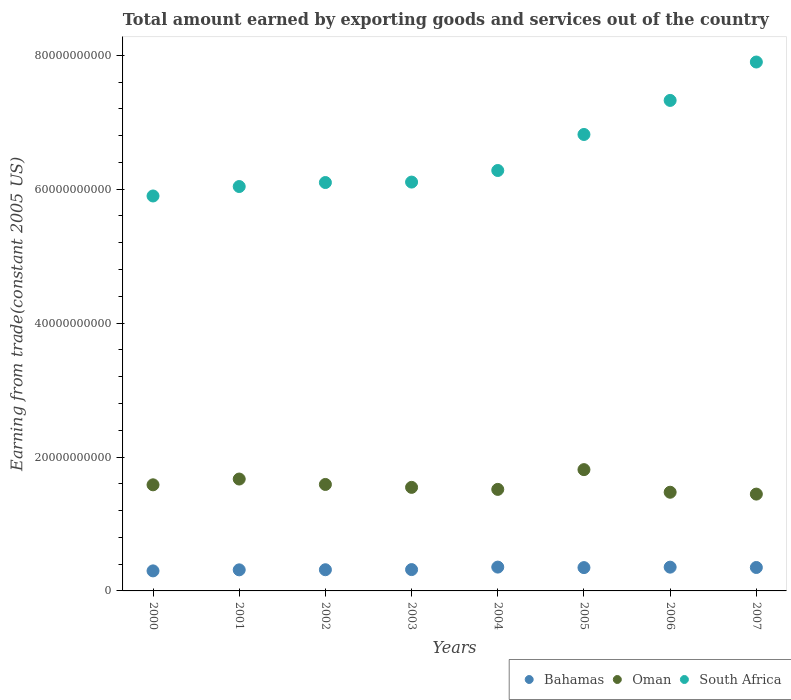How many different coloured dotlines are there?
Keep it short and to the point. 3. Is the number of dotlines equal to the number of legend labels?
Give a very brief answer. Yes. What is the total amount earned by exporting goods and services in Bahamas in 2007?
Your answer should be compact. 3.50e+09. Across all years, what is the maximum total amount earned by exporting goods and services in Oman?
Make the answer very short. 1.81e+1. Across all years, what is the minimum total amount earned by exporting goods and services in South Africa?
Offer a very short reply. 5.90e+1. In which year was the total amount earned by exporting goods and services in South Africa maximum?
Your answer should be very brief. 2007. What is the total total amount earned by exporting goods and services in Oman in the graph?
Give a very brief answer. 1.26e+11. What is the difference between the total amount earned by exporting goods and services in Bahamas in 2001 and that in 2004?
Provide a succinct answer. -4.10e+08. What is the difference between the total amount earned by exporting goods and services in South Africa in 2002 and the total amount earned by exporting goods and services in Bahamas in 2007?
Ensure brevity in your answer.  5.75e+1. What is the average total amount earned by exporting goods and services in Bahamas per year?
Make the answer very short. 3.32e+09. In the year 2002, what is the difference between the total amount earned by exporting goods and services in Bahamas and total amount earned by exporting goods and services in South Africa?
Make the answer very short. -5.78e+1. What is the ratio of the total amount earned by exporting goods and services in South Africa in 2003 to that in 2004?
Provide a short and direct response. 0.97. What is the difference between the highest and the second highest total amount earned by exporting goods and services in South Africa?
Offer a terse response. 5.73e+09. What is the difference between the highest and the lowest total amount earned by exporting goods and services in Bahamas?
Keep it short and to the point. 5.66e+08. In how many years, is the total amount earned by exporting goods and services in South Africa greater than the average total amount earned by exporting goods and services in South Africa taken over all years?
Provide a short and direct response. 3. Is the sum of the total amount earned by exporting goods and services in South Africa in 2001 and 2005 greater than the maximum total amount earned by exporting goods and services in Bahamas across all years?
Ensure brevity in your answer.  Yes. How many dotlines are there?
Your response must be concise. 3. Are the values on the major ticks of Y-axis written in scientific E-notation?
Ensure brevity in your answer.  No. Where does the legend appear in the graph?
Offer a terse response. Bottom right. How many legend labels are there?
Make the answer very short. 3. What is the title of the graph?
Your response must be concise. Total amount earned by exporting goods and services out of the country. What is the label or title of the Y-axis?
Ensure brevity in your answer.  Earning from trade(constant 2005 US). What is the Earning from trade(constant 2005 US) in Bahamas in 2000?
Provide a short and direct response. 2.99e+09. What is the Earning from trade(constant 2005 US) in Oman in 2000?
Offer a very short reply. 1.58e+1. What is the Earning from trade(constant 2005 US) in South Africa in 2000?
Make the answer very short. 5.90e+1. What is the Earning from trade(constant 2005 US) of Bahamas in 2001?
Provide a succinct answer. 3.15e+09. What is the Earning from trade(constant 2005 US) in Oman in 2001?
Ensure brevity in your answer.  1.67e+1. What is the Earning from trade(constant 2005 US) of South Africa in 2001?
Offer a very short reply. 6.04e+1. What is the Earning from trade(constant 2005 US) of Bahamas in 2002?
Provide a succinct answer. 3.16e+09. What is the Earning from trade(constant 2005 US) of Oman in 2002?
Your answer should be compact. 1.59e+1. What is the Earning from trade(constant 2005 US) in South Africa in 2002?
Provide a short and direct response. 6.10e+1. What is the Earning from trade(constant 2005 US) of Bahamas in 2003?
Your answer should be compact. 3.19e+09. What is the Earning from trade(constant 2005 US) of Oman in 2003?
Provide a short and direct response. 1.55e+1. What is the Earning from trade(constant 2005 US) of South Africa in 2003?
Your answer should be compact. 6.11e+1. What is the Earning from trade(constant 2005 US) in Bahamas in 2004?
Make the answer very short. 3.56e+09. What is the Earning from trade(constant 2005 US) of Oman in 2004?
Keep it short and to the point. 1.52e+1. What is the Earning from trade(constant 2005 US) in South Africa in 2004?
Make the answer very short. 6.28e+1. What is the Earning from trade(constant 2005 US) in Bahamas in 2005?
Provide a succinct answer. 3.48e+09. What is the Earning from trade(constant 2005 US) in Oman in 2005?
Make the answer very short. 1.81e+1. What is the Earning from trade(constant 2005 US) in South Africa in 2005?
Your response must be concise. 6.82e+1. What is the Earning from trade(constant 2005 US) of Bahamas in 2006?
Offer a terse response. 3.55e+09. What is the Earning from trade(constant 2005 US) in Oman in 2006?
Offer a terse response. 1.47e+1. What is the Earning from trade(constant 2005 US) of South Africa in 2006?
Your response must be concise. 7.33e+1. What is the Earning from trade(constant 2005 US) of Bahamas in 2007?
Ensure brevity in your answer.  3.50e+09. What is the Earning from trade(constant 2005 US) in Oman in 2007?
Provide a succinct answer. 1.45e+1. What is the Earning from trade(constant 2005 US) in South Africa in 2007?
Your answer should be compact. 7.90e+1. Across all years, what is the maximum Earning from trade(constant 2005 US) of Bahamas?
Your answer should be very brief. 3.56e+09. Across all years, what is the maximum Earning from trade(constant 2005 US) in Oman?
Your response must be concise. 1.81e+1. Across all years, what is the maximum Earning from trade(constant 2005 US) in South Africa?
Your answer should be compact. 7.90e+1. Across all years, what is the minimum Earning from trade(constant 2005 US) of Bahamas?
Ensure brevity in your answer.  2.99e+09. Across all years, what is the minimum Earning from trade(constant 2005 US) of Oman?
Your response must be concise. 1.45e+1. Across all years, what is the minimum Earning from trade(constant 2005 US) in South Africa?
Offer a very short reply. 5.90e+1. What is the total Earning from trade(constant 2005 US) of Bahamas in the graph?
Your answer should be compact. 2.66e+1. What is the total Earning from trade(constant 2005 US) in Oman in the graph?
Give a very brief answer. 1.26e+11. What is the total Earning from trade(constant 2005 US) in South Africa in the graph?
Offer a very short reply. 5.25e+11. What is the difference between the Earning from trade(constant 2005 US) of Bahamas in 2000 and that in 2001?
Give a very brief answer. -1.55e+08. What is the difference between the Earning from trade(constant 2005 US) of Oman in 2000 and that in 2001?
Provide a succinct answer. -8.64e+08. What is the difference between the Earning from trade(constant 2005 US) in South Africa in 2000 and that in 2001?
Your answer should be very brief. -1.41e+09. What is the difference between the Earning from trade(constant 2005 US) in Bahamas in 2000 and that in 2002?
Keep it short and to the point. -1.72e+08. What is the difference between the Earning from trade(constant 2005 US) of Oman in 2000 and that in 2002?
Keep it short and to the point. -5.48e+07. What is the difference between the Earning from trade(constant 2005 US) of South Africa in 2000 and that in 2002?
Provide a short and direct response. -2.01e+09. What is the difference between the Earning from trade(constant 2005 US) of Bahamas in 2000 and that in 2003?
Your response must be concise. -1.93e+08. What is the difference between the Earning from trade(constant 2005 US) in Oman in 2000 and that in 2003?
Your answer should be very brief. 3.80e+08. What is the difference between the Earning from trade(constant 2005 US) of South Africa in 2000 and that in 2003?
Offer a terse response. -2.08e+09. What is the difference between the Earning from trade(constant 2005 US) in Bahamas in 2000 and that in 2004?
Offer a very short reply. -5.66e+08. What is the difference between the Earning from trade(constant 2005 US) of Oman in 2000 and that in 2004?
Offer a very short reply. 6.82e+08. What is the difference between the Earning from trade(constant 2005 US) of South Africa in 2000 and that in 2004?
Offer a very short reply. -3.81e+09. What is the difference between the Earning from trade(constant 2005 US) of Bahamas in 2000 and that in 2005?
Provide a short and direct response. -4.90e+08. What is the difference between the Earning from trade(constant 2005 US) of Oman in 2000 and that in 2005?
Provide a short and direct response. -2.27e+09. What is the difference between the Earning from trade(constant 2005 US) in South Africa in 2000 and that in 2005?
Your response must be concise. -9.19e+09. What is the difference between the Earning from trade(constant 2005 US) in Bahamas in 2000 and that in 2006?
Your answer should be compact. -5.57e+08. What is the difference between the Earning from trade(constant 2005 US) in Oman in 2000 and that in 2006?
Your response must be concise. 1.11e+09. What is the difference between the Earning from trade(constant 2005 US) in South Africa in 2000 and that in 2006?
Keep it short and to the point. -1.43e+1. What is the difference between the Earning from trade(constant 2005 US) in Bahamas in 2000 and that in 2007?
Your answer should be very brief. -5.07e+08. What is the difference between the Earning from trade(constant 2005 US) of Oman in 2000 and that in 2007?
Provide a succinct answer. 1.39e+09. What is the difference between the Earning from trade(constant 2005 US) of South Africa in 2000 and that in 2007?
Give a very brief answer. -2.00e+1. What is the difference between the Earning from trade(constant 2005 US) in Bahamas in 2001 and that in 2002?
Ensure brevity in your answer.  -1.64e+07. What is the difference between the Earning from trade(constant 2005 US) of Oman in 2001 and that in 2002?
Ensure brevity in your answer.  8.09e+08. What is the difference between the Earning from trade(constant 2005 US) in South Africa in 2001 and that in 2002?
Your response must be concise. -5.97e+08. What is the difference between the Earning from trade(constant 2005 US) in Bahamas in 2001 and that in 2003?
Ensure brevity in your answer.  -3.78e+07. What is the difference between the Earning from trade(constant 2005 US) in Oman in 2001 and that in 2003?
Your response must be concise. 1.24e+09. What is the difference between the Earning from trade(constant 2005 US) in South Africa in 2001 and that in 2003?
Make the answer very short. -6.64e+08. What is the difference between the Earning from trade(constant 2005 US) in Bahamas in 2001 and that in 2004?
Your response must be concise. -4.10e+08. What is the difference between the Earning from trade(constant 2005 US) in Oman in 2001 and that in 2004?
Your response must be concise. 1.55e+09. What is the difference between the Earning from trade(constant 2005 US) of South Africa in 2001 and that in 2004?
Make the answer very short. -2.39e+09. What is the difference between the Earning from trade(constant 2005 US) of Bahamas in 2001 and that in 2005?
Give a very brief answer. -3.34e+08. What is the difference between the Earning from trade(constant 2005 US) of Oman in 2001 and that in 2005?
Keep it short and to the point. -1.40e+09. What is the difference between the Earning from trade(constant 2005 US) in South Africa in 2001 and that in 2005?
Offer a terse response. -7.77e+09. What is the difference between the Earning from trade(constant 2005 US) in Bahamas in 2001 and that in 2006?
Your response must be concise. -4.02e+08. What is the difference between the Earning from trade(constant 2005 US) of Oman in 2001 and that in 2006?
Give a very brief answer. 1.97e+09. What is the difference between the Earning from trade(constant 2005 US) in South Africa in 2001 and that in 2006?
Make the answer very short. -1.29e+1. What is the difference between the Earning from trade(constant 2005 US) in Bahamas in 2001 and that in 2007?
Ensure brevity in your answer.  -3.51e+08. What is the difference between the Earning from trade(constant 2005 US) of Oman in 2001 and that in 2007?
Offer a very short reply. 2.25e+09. What is the difference between the Earning from trade(constant 2005 US) of South Africa in 2001 and that in 2007?
Your response must be concise. -1.86e+1. What is the difference between the Earning from trade(constant 2005 US) of Bahamas in 2002 and that in 2003?
Your answer should be compact. -2.14e+07. What is the difference between the Earning from trade(constant 2005 US) in Oman in 2002 and that in 2003?
Ensure brevity in your answer.  4.35e+08. What is the difference between the Earning from trade(constant 2005 US) in South Africa in 2002 and that in 2003?
Offer a terse response. -6.67e+07. What is the difference between the Earning from trade(constant 2005 US) in Bahamas in 2002 and that in 2004?
Ensure brevity in your answer.  -3.94e+08. What is the difference between the Earning from trade(constant 2005 US) in Oman in 2002 and that in 2004?
Ensure brevity in your answer.  7.36e+08. What is the difference between the Earning from trade(constant 2005 US) in South Africa in 2002 and that in 2004?
Provide a succinct answer. -1.80e+09. What is the difference between the Earning from trade(constant 2005 US) of Bahamas in 2002 and that in 2005?
Provide a succinct answer. -3.18e+08. What is the difference between the Earning from trade(constant 2005 US) in Oman in 2002 and that in 2005?
Provide a short and direct response. -2.21e+09. What is the difference between the Earning from trade(constant 2005 US) of South Africa in 2002 and that in 2005?
Ensure brevity in your answer.  -7.18e+09. What is the difference between the Earning from trade(constant 2005 US) of Bahamas in 2002 and that in 2006?
Give a very brief answer. -3.86e+08. What is the difference between the Earning from trade(constant 2005 US) of Oman in 2002 and that in 2006?
Your answer should be compact. 1.16e+09. What is the difference between the Earning from trade(constant 2005 US) in South Africa in 2002 and that in 2006?
Your answer should be very brief. -1.23e+1. What is the difference between the Earning from trade(constant 2005 US) in Bahamas in 2002 and that in 2007?
Give a very brief answer. -3.35e+08. What is the difference between the Earning from trade(constant 2005 US) in Oman in 2002 and that in 2007?
Keep it short and to the point. 1.44e+09. What is the difference between the Earning from trade(constant 2005 US) in South Africa in 2002 and that in 2007?
Your answer should be compact. -1.80e+1. What is the difference between the Earning from trade(constant 2005 US) of Bahamas in 2003 and that in 2004?
Make the answer very short. -3.73e+08. What is the difference between the Earning from trade(constant 2005 US) in Oman in 2003 and that in 2004?
Your answer should be compact. 3.01e+08. What is the difference between the Earning from trade(constant 2005 US) in South Africa in 2003 and that in 2004?
Your answer should be very brief. -1.73e+09. What is the difference between the Earning from trade(constant 2005 US) of Bahamas in 2003 and that in 2005?
Ensure brevity in your answer.  -2.96e+08. What is the difference between the Earning from trade(constant 2005 US) in Oman in 2003 and that in 2005?
Make the answer very short. -2.65e+09. What is the difference between the Earning from trade(constant 2005 US) of South Africa in 2003 and that in 2005?
Keep it short and to the point. -7.11e+09. What is the difference between the Earning from trade(constant 2005 US) of Bahamas in 2003 and that in 2006?
Your response must be concise. -3.64e+08. What is the difference between the Earning from trade(constant 2005 US) of Oman in 2003 and that in 2006?
Give a very brief answer. 7.28e+08. What is the difference between the Earning from trade(constant 2005 US) in South Africa in 2003 and that in 2006?
Ensure brevity in your answer.  -1.22e+1. What is the difference between the Earning from trade(constant 2005 US) of Bahamas in 2003 and that in 2007?
Provide a short and direct response. -3.14e+08. What is the difference between the Earning from trade(constant 2005 US) of Oman in 2003 and that in 2007?
Give a very brief answer. 1.00e+09. What is the difference between the Earning from trade(constant 2005 US) in South Africa in 2003 and that in 2007?
Your response must be concise. -1.79e+1. What is the difference between the Earning from trade(constant 2005 US) in Bahamas in 2004 and that in 2005?
Your answer should be very brief. 7.62e+07. What is the difference between the Earning from trade(constant 2005 US) of Oman in 2004 and that in 2005?
Ensure brevity in your answer.  -2.95e+09. What is the difference between the Earning from trade(constant 2005 US) in South Africa in 2004 and that in 2005?
Your response must be concise. -5.38e+09. What is the difference between the Earning from trade(constant 2005 US) in Bahamas in 2004 and that in 2006?
Make the answer very short. 8.46e+06. What is the difference between the Earning from trade(constant 2005 US) of Oman in 2004 and that in 2006?
Provide a short and direct response. 4.27e+08. What is the difference between the Earning from trade(constant 2005 US) of South Africa in 2004 and that in 2006?
Your answer should be very brief. -1.05e+1. What is the difference between the Earning from trade(constant 2005 US) of Bahamas in 2004 and that in 2007?
Ensure brevity in your answer.  5.91e+07. What is the difference between the Earning from trade(constant 2005 US) in Oman in 2004 and that in 2007?
Offer a terse response. 7.04e+08. What is the difference between the Earning from trade(constant 2005 US) of South Africa in 2004 and that in 2007?
Make the answer very short. -1.62e+1. What is the difference between the Earning from trade(constant 2005 US) of Bahamas in 2005 and that in 2006?
Provide a succinct answer. -6.77e+07. What is the difference between the Earning from trade(constant 2005 US) in Oman in 2005 and that in 2006?
Provide a succinct answer. 3.38e+09. What is the difference between the Earning from trade(constant 2005 US) of South Africa in 2005 and that in 2006?
Your answer should be compact. -5.09e+09. What is the difference between the Earning from trade(constant 2005 US) in Bahamas in 2005 and that in 2007?
Provide a succinct answer. -1.71e+07. What is the difference between the Earning from trade(constant 2005 US) in Oman in 2005 and that in 2007?
Ensure brevity in your answer.  3.65e+09. What is the difference between the Earning from trade(constant 2005 US) in South Africa in 2005 and that in 2007?
Provide a short and direct response. -1.08e+1. What is the difference between the Earning from trade(constant 2005 US) in Bahamas in 2006 and that in 2007?
Offer a very short reply. 5.06e+07. What is the difference between the Earning from trade(constant 2005 US) of Oman in 2006 and that in 2007?
Your answer should be very brief. 2.77e+08. What is the difference between the Earning from trade(constant 2005 US) of South Africa in 2006 and that in 2007?
Keep it short and to the point. -5.73e+09. What is the difference between the Earning from trade(constant 2005 US) in Bahamas in 2000 and the Earning from trade(constant 2005 US) in Oman in 2001?
Provide a succinct answer. -1.37e+1. What is the difference between the Earning from trade(constant 2005 US) in Bahamas in 2000 and the Earning from trade(constant 2005 US) in South Africa in 2001?
Offer a terse response. -5.74e+1. What is the difference between the Earning from trade(constant 2005 US) of Oman in 2000 and the Earning from trade(constant 2005 US) of South Africa in 2001?
Your answer should be very brief. -4.46e+1. What is the difference between the Earning from trade(constant 2005 US) of Bahamas in 2000 and the Earning from trade(constant 2005 US) of Oman in 2002?
Your answer should be compact. -1.29e+1. What is the difference between the Earning from trade(constant 2005 US) in Bahamas in 2000 and the Earning from trade(constant 2005 US) in South Africa in 2002?
Offer a terse response. -5.80e+1. What is the difference between the Earning from trade(constant 2005 US) of Oman in 2000 and the Earning from trade(constant 2005 US) of South Africa in 2002?
Offer a very short reply. -4.51e+1. What is the difference between the Earning from trade(constant 2005 US) in Bahamas in 2000 and the Earning from trade(constant 2005 US) in Oman in 2003?
Offer a terse response. -1.25e+1. What is the difference between the Earning from trade(constant 2005 US) in Bahamas in 2000 and the Earning from trade(constant 2005 US) in South Africa in 2003?
Make the answer very short. -5.81e+1. What is the difference between the Earning from trade(constant 2005 US) in Oman in 2000 and the Earning from trade(constant 2005 US) in South Africa in 2003?
Keep it short and to the point. -4.52e+1. What is the difference between the Earning from trade(constant 2005 US) of Bahamas in 2000 and the Earning from trade(constant 2005 US) of Oman in 2004?
Provide a short and direct response. -1.22e+1. What is the difference between the Earning from trade(constant 2005 US) of Bahamas in 2000 and the Earning from trade(constant 2005 US) of South Africa in 2004?
Your answer should be compact. -5.98e+1. What is the difference between the Earning from trade(constant 2005 US) in Oman in 2000 and the Earning from trade(constant 2005 US) in South Africa in 2004?
Ensure brevity in your answer.  -4.69e+1. What is the difference between the Earning from trade(constant 2005 US) of Bahamas in 2000 and the Earning from trade(constant 2005 US) of Oman in 2005?
Provide a succinct answer. -1.51e+1. What is the difference between the Earning from trade(constant 2005 US) of Bahamas in 2000 and the Earning from trade(constant 2005 US) of South Africa in 2005?
Provide a succinct answer. -6.52e+1. What is the difference between the Earning from trade(constant 2005 US) in Oman in 2000 and the Earning from trade(constant 2005 US) in South Africa in 2005?
Keep it short and to the point. -5.23e+1. What is the difference between the Earning from trade(constant 2005 US) of Bahamas in 2000 and the Earning from trade(constant 2005 US) of Oman in 2006?
Provide a short and direct response. -1.17e+1. What is the difference between the Earning from trade(constant 2005 US) in Bahamas in 2000 and the Earning from trade(constant 2005 US) in South Africa in 2006?
Offer a terse response. -7.03e+1. What is the difference between the Earning from trade(constant 2005 US) of Oman in 2000 and the Earning from trade(constant 2005 US) of South Africa in 2006?
Give a very brief answer. -5.74e+1. What is the difference between the Earning from trade(constant 2005 US) in Bahamas in 2000 and the Earning from trade(constant 2005 US) in Oman in 2007?
Give a very brief answer. -1.15e+1. What is the difference between the Earning from trade(constant 2005 US) in Bahamas in 2000 and the Earning from trade(constant 2005 US) in South Africa in 2007?
Provide a short and direct response. -7.60e+1. What is the difference between the Earning from trade(constant 2005 US) in Oman in 2000 and the Earning from trade(constant 2005 US) in South Africa in 2007?
Your answer should be very brief. -6.31e+1. What is the difference between the Earning from trade(constant 2005 US) of Bahamas in 2001 and the Earning from trade(constant 2005 US) of Oman in 2002?
Your answer should be compact. -1.28e+1. What is the difference between the Earning from trade(constant 2005 US) in Bahamas in 2001 and the Earning from trade(constant 2005 US) in South Africa in 2002?
Offer a terse response. -5.78e+1. What is the difference between the Earning from trade(constant 2005 US) in Oman in 2001 and the Earning from trade(constant 2005 US) in South Africa in 2002?
Make the answer very short. -4.43e+1. What is the difference between the Earning from trade(constant 2005 US) in Bahamas in 2001 and the Earning from trade(constant 2005 US) in Oman in 2003?
Provide a succinct answer. -1.23e+1. What is the difference between the Earning from trade(constant 2005 US) in Bahamas in 2001 and the Earning from trade(constant 2005 US) in South Africa in 2003?
Your response must be concise. -5.79e+1. What is the difference between the Earning from trade(constant 2005 US) in Oman in 2001 and the Earning from trade(constant 2005 US) in South Africa in 2003?
Provide a short and direct response. -4.44e+1. What is the difference between the Earning from trade(constant 2005 US) in Bahamas in 2001 and the Earning from trade(constant 2005 US) in Oman in 2004?
Ensure brevity in your answer.  -1.20e+1. What is the difference between the Earning from trade(constant 2005 US) of Bahamas in 2001 and the Earning from trade(constant 2005 US) of South Africa in 2004?
Provide a short and direct response. -5.96e+1. What is the difference between the Earning from trade(constant 2005 US) of Oman in 2001 and the Earning from trade(constant 2005 US) of South Africa in 2004?
Offer a terse response. -4.61e+1. What is the difference between the Earning from trade(constant 2005 US) of Bahamas in 2001 and the Earning from trade(constant 2005 US) of Oman in 2005?
Keep it short and to the point. -1.50e+1. What is the difference between the Earning from trade(constant 2005 US) in Bahamas in 2001 and the Earning from trade(constant 2005 US) in South Africa in 2005?
Keep it short and to the point. -6.50e+1. What is the difference between the Earning from trade(constant 2005 US) in Oman in 2001 and the Earning from trade(constant 2005 US) in South Africa in 2005?
Offer a terse response. -5.15e+1. What is the difference between the Earning from trade(constant 2005 US) of Bahamas in 2001 and the Earning from trade(constant 2005 US) of Oman in 2006?
Your answer should be compact. -1.16e+1. What is the difference between the Earning from trade(constant 2005 US) of Bahamas in 2001 and the Earning from trade(constant 2005 US) of South Africa in 2006?
Keep it short and to the point. -7.01e+1. What is the difference between the Earning from trade(constant 2005 US) of Oman in 2001 and the Earning from trade(constant 2005 US) of South Africa in 2006?
Offer a terse response. -5.65e+1. What is the difference between the Earning from trade(constant 2005 US) in Bahamas in 2001 and the Earning from trade(constant 2005 US) in Oman in 2007?
Provide a short and direct response. -1.13e+1. What is the difference between the Earning from trade(constant 2005 US) of Bahamas in 2001 and the Earning from trade(constant 2005 US) of South Africa in 2007?
Make the answer very short. -7.58e+1. What is the difference between the Earning from trade(constant 2005 US) of Oman in 2001 and the Earning from trade(constant 2005 US) of South Africa in 2007?
Ensure brevity in your answer.  -6.23e+1. What is the difference between the Earning from trade(constant 2005 US) in Bahamas in 2002 and the Earning from trade(constant 2005 US) in Oman in 2003?
Offer a terse response. -1.23e+1. What is the difference between the Earning from trade(constant 2005 US) in Bahamas in 2002 and the Earning from trade(constant 2005 US) in South Africa in 2003?
Give a very brief answer. -5.79e+1. What is the difference between the Earning from trade(constant 2005 US) of Oman in 2002 and the Earning from trade(constant 2005 US) of South Africa in 2003?
Your answer should be compact. -4.52e+1. What is the difference between the Earning from trade(constant 2005 US) of Bahamas in 2002 and the Earning from trade(constant 2005 US) of Oman in 2004?
Give a very brief answer. -1.20e+1. What is the difference between the Earning from trade(constant 2005 US) of Bahamas in 2002 and the Earning from trade(constant 2005 US) of South Africa in 2004?
Give a very brief answer. -5.96e+1. What is the difference between the Earning from trade(constant 2005 US) of Oman in 2002 and the Earning from trade(constant 2005 US) of South Africa in 2004?
Make the answer very short. -4.69e+1. What is the difference between the Earning from trade(constant 2005 US) in Bahamas in 2002 and the Earning from trade(constant 2005 US) in Oman in 2005?
Give a very brief answer. -1.50e+1. What is the difference between the Earning from trade(constant 2005 US) in Bahamas in 2002 and the Earning from trade(constant 2005 US) in South Africa in 2005?
Offer a very short reply. -6.50e+1. What is the difference between the Earning from trade(constant 2005 US) of Oman in 2002 and the Earning from trade(constant 2005 US) of South Africa in 2005?
Ensure brevity in your answer.  -5.23e+1. What is the difference between the Earning from trade(constant 2005 US) of Bahamas in 2002 and the Earning from trade(constant 2005 US) of Oman in 2006?
Provide a succinct answer. -1.16e+1. What is the difference between the Earning from trade(constant 2005 US) in Bahamas in 2002 and the Earning from trade(constant 2005 US) in South Africa in 2006?
Give a very brief answer. -7.01e+1. What is the difference between the Earning from trade(constant 2005 US) in Oman in 2002 and the Earning from trade(constant 2005 US) in South Africa in 2006?
Keep it short and to the point. -5.74e+1. What is the difference between the Earning from trade(constant 2005 US) of Bahamas in 2002 and the Earning from trade(constant 2005 US) of Oman in 2007?
Offer a terse response. -1.13e+1. What is the difference between the Earning from trade(constant 2005 US) of Bahamas in 2002 and the Earning from trade(constant 2005 US) of South Africa in 2007?
Your answer should be compact. -7.58e+1. What is the difference between the Earning from trade(constant 2005 US) of Oman in 2002 and the Earning from trade(constant 2005 US) of South Africa in 2007?
Ensure brevity in your answer.  -6.31e+1. What is the difference between the Earning from trade(constant 2005 US) in Bahamas in 2003 and the Earning from trade(constant 2005 US) in Oman in 2004?
Your answer should be very brief. -1.20e+1. What is the difference between the Earning from trade(constant 2005 US) of Bahamas in 2003 and the Earning from trade(constant 2005 US) of South Africa in 2004?
Keep it short and to the point. -5.96e+1. What is the difference between the Earning from trade(constant 2005 US) in Oman in 2003 and the Earning from trade(constant 2005 US) in South Africa in 2004?
Give a very brief answer. -4.73e+1. What is the difference between the Earning from trade(constant 2005 US) in Bahamas in 2003 and the Earning from trade(constant 2005 US) in Oman in 2005?
Provide a short and direct response. -1.49e+1. What is the difference between the Earning from trade(constant 2005 US) in Bahamas in 2003 and the Earning from trade(constant 2005 US) in South Africa in 2005?
Make the answer very short. -6.50e+1. What is the difference between the Earning from trade(constant 2005 US) of Oman in 2003 and the Earning from trade(constant 2005 US) of South Africa in 2005?
Make the answer very short. -5.27e+1. What is the difference between the Earning from trade(constant 2005 US) in Bahamas in 2003 and the Earning from trade(constant 2005 US) in Oman in 2006?
Provide a succinct answer. -1.16e+1. What is the difference between the Earning from trade(constant 2005 US) in Bahamas in 2003 and the Earning from trade(constant 2005 US) in South Africa in 2006?
Offer a very short reply. -7.01e+1. What is the difference between the Earning from trade(constant 2005 US) of Oman in 2003 and the Earning from trade(constant 2005 US) of South Africa in 2006?
Ensure brevity in your answer.  -5.78e+1. What is the difference between the Earning from trade(constant 2005 US) of Bahamas in 2003 and the Earning from trade(constant 2005 US) of Oman in 2007?
Your answer should be compact. -1.13e+1. What is the difference between the Earning from trade(constant 2005 US) in Bahamas in 2003 and the Earning from trade(constant 2005 US) in South Africa in 2007?
Keep it short and to the point. -7.58e+1. What is the difference between the Earning from trade(constant 2005 US) of Oman in 2003 and the Earning from trade(constant 2005 US) of South Africa in 2007?
Your response must be concise. -6.35e+1. What is the difference between the Earning from trade(constant 2005 US) of Bahamas in 2004 and the Earning from trade(constant 2005 US) of Oman in 2005?
Make the answer very short. -1.46e+1. What is the difference between the Earning from trade(constant 2005 US) of Bahamas in 2004 and the Earning from trade(constant 2005 US) of South Africa in 2005?
Offer a terse response. -6.46e+1. What is the difference between the Earning from trade(constant 2005 US) in Oman in 2004 and the Earning from trade(constant 2005 US) in South Africa in 2005?
Give a very brief answer. -5.30e+1. What is the difference between the Earning from trade(constant 2005 US) of Bahamas in 2004 and the Earning from trade(constant 2005 US) of Oman in 2006?
Give a very brief answer. -1.12e+1. What is the difference between the Earning from trade(constant 2005 US) of Bahamas in 2004 and the Earning from trade(constant 2005 US) of South Africa in 2006?
Provide a short and direct response. -6.97e+1. What is the difference between the Earning from trade(constant 2005 US) of Oman in 2004 and the Earning from trade(constant 2005 US) of South Africa in 2006?
Provide a short and direct response. -5.81e+1. What is the difference between the Earning from trade(constant 2005 US) in Bahamas in 2004 and the Earning from trade(constant 2005 US) in Oman in 2007?
Keep it short and to the point. -1.09e+1. What is the difference between the Earning from trade(constant 2005 US) in Bahamas in 2004 and the Earning from trade(constant 2005 US) in South Africa in 2007?
Offer a terse response. -7.54e+1. What is the difference between the Earning from trade(constant 2005 US) of Oman in 2004 and the Earning from trade(constant 2005 US) of South Africa in 2007?
Make the answer very short. -6.38e+1. What is the difference between the Earning from trade(constant 2005 US) of Bahamas in 2005 and the Earning from trade(constant 2005 US) of Oman in 2006?
Offer a terse response. -1.13e+1. What is the difference between the Earning from trade(constant 2005 US) of Bahamas in 2005 and the Earning from trade(constant 2005 US) of South Africa in 2006?
Give a very brief answer. -6.98e+1. What is the difference between the Earning from trade(constant 2005 US) of Oman in 2005 and the Earning from trade(constant 2005 US) of South Africa in 2006?
Provide a succinct answer. -5.51e+1. What is the difference between the Earning from trade(constant 2005 US) of Bahamas in 2005 and the Earning from trade(constant 2005 US) of Oman in 2007?
Make the answer very short. -1.10e+1. What is the difference between the Earning from trade(constant 2005 US) in Bahamas in 2005 and the Earning from trade(constant 2005 US) in South Africa in 2007?
Keep it short and to the point. -7.55e+1. What is the difference between the Earning from trade(constant 2005 US) in Oman in 2005 and the Earning from trade(constant 2005 US) in South Africa in 2007?
Your answer should be compact. -6.09e+1. What is the difference between the Earning from trade(constant 2005 US) in Bahamas in 2006 and the Earning from trade(constant 2005 US) in Oman in 2007?
Provide a short and direct response. -1.09e+1. What is the difference between the Earning from trade(constant 2005 US) of Bahamas in 2006 and the Earning from trade(constant 2005 US) of South Africa in 2007?
Provide a short and direct response. -7.54e+1. What is the difference between the Earning from trade(constant 2005 US) in Oman in 2006 and the Earning from trade(constant 2005 US) in South Africa in 2007?
Make the answer very short. -6.43e+1. What is the average Earning from trade(constant 2005 US) in Bahamas per year?
Your answer should be very brief. 3.32e+09. What is the average Earning from trade(constant 2005 US) in Oman per year?
Your answer should be very brief. 1.58e+1. What is the average Earning from trade(constant 2005 US) of South Africa per year?
Offer a terse response. 6.56e+1. In the year 2000, what is the difference between the Earning from trade(constant 2005 US) in Bahamas and Earning from trade(constant 2005 US) in Oman?
Offer a very short reply. -1.29e+1. In the year 2000, what is the difference between the Earning from trade(constant 2005 US) in Bahamas and Earning from trade(constant 2005 US) in South Africa?
Offer a very short reply. -5.60e+1. In the year 2000, what is the difference between the Earning from trade(constant 2005 US) of Oman and Earning from trade(constant 2005 US) of South Africa?
Offer a terse response. -4.31e+1. In the year 2001, what is the difference between the Earning from trade(constant 2005 US) of Bahamas and Earning from trade(constant 2005 US) of Oman?
Offer a terse response. -1.36e+1. In the year 2001, what is the difference between the Earning from trade(constant 2005 US) of Bahamas and Earning from trade(constant 2005 US) of South Africa?
Offer a very short reply. -5.72e+1. In the year 2001, what is the difference between the Earning from trade(constant 2005 US) of Oman and Earning from trade(constant 2005 US) of South Africa?
Ensure brevity in your answer.  -4.37e+1. In the year 2002, what is the difference between the Earning from trade(constant 2005 US) of Bahamas and Earning from trade(constant 2005 US) of Oman?
Ensure brevity in your answer.  -1.27e+1. In the year 2002, what is the difference between the Earning from trade(constant 2005 US) in Bahamas and Earning from trade(constant 2005 US) in South Africa?
Offer a very short reply. -5.78e+1. In the year 2002, what is the difference between the Earning from trade(constant 2005 US) in Oman and Earning from trade(constant 2005 US) in South Africa?
Keep it short and to the point. -4.51e+1. In the year 2003, what is the difference between the Earning from trade(constant 2005 US) of Bahamas and Earning from trade(constant 2005 US) of Oman?
Give a very brief answer. -1.23e+1. In the year 2003, what is the difference between the Earning from trade(constant 2005 US) in Bahamas and Earning from trade(constant 2005 US) in South Africa?
Offer a very short reply. -5.79e+1. In the year 2003, what is the difference between the Earning from trade(constant 2005 US) of Oman and Earning from trade(constant 2005 US) of South Africa?
Ensure brevity in your answer.  -4.56e+1. In the year 2004, what is the difference between the Earning from trade(constant 2005 US) of Bahamas and Earning from trade(constant 2005 US) of Oman?
Provide a short and direct response. -1.16e+1. In the year 2004, what is the difference between the Earning from trade(constant 2005 US) of Bahamas and Earning from trade(constant 2005 US) of South Africa?
Ensure brevity in your answer.  -5.92e+1. In the year 2004, what is the difference between the Earning from trade(constant 2005 US) in Oman and Earning from trade(constant 2005 US) in South Africa?
Offer a terse response. -4.76e+1. In the year 2005, what is the difference between the Earning from trade(constant 2005 US) of Bahamas and Earning from trade(constant 2005 US) of Oman?
Provide a succinct answer. -1.46e+1. In the year 2005, what is the difference between the Earning from trade(constant 2005 US) of Bahamas and Earning from trade(constant 2005 US) of South Africa?
Offer a very short reply. -6.47e+1. In the year 2005, what is the difference between the Earning from trade(constant 2005 US) of Oman and Earning from trade(constant 2005 US) of South Africa?
Give a very brief answer. -5.01e+1. In the year 2006, what is the difference between the Earning from trade(constant 2005 US) of Bahamas and Earning from trade(constant 2005 US) of Oman?
Your answer should be very brief. -1.12e+1. In the year 2006, what is the difference between the Earning from trade(constant 2005 US) of Bahamas and Earning from trade(constant 2005 US) of South Africa?
Offer a very short reply. -6.97e+1. In the year 2006, what is the difference between the Earning from trade(constant 2005 US) of Oman and Earning from trade(constant 2005 US) of South Africa?
Keep it short and to the point. -5.85e+1. In the year 2007, what is the difference between the Earning from trade(constant 2005 US) in Bahamas and Earning from trade(constant 2005 US) in Oman?
Offer a very short reply. -1.10e+1. In the year 2007, what is the difference between the Earning from trade(constant 2005 US) of Bahamas and Earning from trade(constant 2005 US) of South Africa?
Offer a very short reply. -7.55e+1. In the year 2007, what is the difference between the Earning from trade(constant 2005 US) in Oman and Earning from trade(constant 2005 US) in South Africa?
Offer a very short reply. -6.45e+1. What is the ratio of the Earning from trade(constant 2005 US) of Bahamas in 2000 to that in 2001?
Your answer should be very brief. 0.95. What is the ratio of the Earning from trade(constant 2005 US) of Oman in 2000 to that in 2001?
Keep it short and to the point. 0.95. What is the ratio of the Earning from trade(constant 2005 US) of South Africa in 2000 to that in 2001?
Provide a succinct answer. 0.98. What is the ratio of the Earning from trade(constant 2005 US) of Bahamas in 2000 to that in 2002?
Give a very brief answer. 0.95. What is the ratio of the Earning from trade(constant 2005 US) of Oman in 2000 to that in 2002?
Your response must be concise. 1. What is the ratio of the Earning from trade(constant 2005 US) of South Africa in 2000 to that in 2002?
Keep it short and to the point. 0.97. What is the ratio of the Earning from trade(constant 2005 US) in Bahamas in 2000 to that in 2003?
Make the answer very short. 0.94. What is the ratio of the Earning from trade(constant 2005 US) of Oman in 2000 to that in 2003?
Provide a succinct answer. 1.02. What is the ratio of the Earning from trade(constant 2005 US) of South Africa in 2000 to that in 2003?
Offer a terse response. 0.97. What is the ratio of the Earning from trade(constant 2005 US) in Bahamas in 2000 to that in 2004?
Give a very brief answer. 0.84. What is the ratio of the Earning from trade(constant 2005 US) of Oman in 2000 to that in 2004?
Keep it short and to the point. 1.04. What is the ratio of the Earning from trade(constant 2005 US) in South Africa in 2000 to that in 2004?
Your answer should be very brief. 0.94. What is the ratio of the Earning from trade(constant 2005 US) of Bahamas in 2000 to that in 2005?
Offer a very short reply. 0.86. What is the ratio of the Earning from trade(constant 2005 US) of Oman in 2000 to that in 2005?
Your answer should be very brief. 0.87. What is the ratio of the Earning from trade(constant 2005 US) in South Africa in 2000 to that in 2005?
Make the answer very short. 0.87. What is the ratio of the Earning from trade(constant 2005 US) in Bahamas in 2000 to that in 2006?
Provide a succinct answer. 0.84. What is the ratio of the Earning from trade(constant 2005 US) of Oman in 2000 to that in 2006?
Keep it short and to the point. 1.08. What is the ratio of the Earning from trade(constant 2005 US) in South Africa in 2000 to that in 2006?
Ensure brevity in your answer.  0.81. What is the ratio of the Earning from trade(constant 2005 US) in Bahamas in 2000 to that in 2007?
Your answer should be very brief. 0.86. What is the ratio of the Earning from trade(constant 2005 US) of Oman in 2000 to that in 2007?
Offer a very short reply. 1.1. What is the ratio of the Earning from trade(constant 2005 US) of South Africa in 2000 to that in 2007?
Provide a short and direct response. 0.75. What is the ratio of the Earning from trade(constant 2005 US) of Oman in 2001 to that in 2002?
Your answer should be very brief. 1.05. What is the ratio of the Earning from trade(constant 2005 US) of South Africa in 2001 to that in 2002?
Offer a terse response. 0.99. What is the ratio of the Earning from trade(constant 2005 US) in Bahamas in 2001 to that in 2003?
Your answer should be very brief. 0.99. What is the ratio of the Earning from trade(constant 2005 US) in Oman in 2001 to that in 2003?
Make the answer very short. 1.08. What is the ratio of the Earning from trade(constant 2005 US) of Bahamas in 2001 to that in 2004?
Offer a terse response. 0.88. What is the ratio of the Earning from trade(constant 2005 US) in Oman in 2001 to that in 2004?
Your response must be concise. 1.1. What is the ratio of the Earning from trade(constant 2005 US) in South Africa in 2001 to that in 2004?
Your answer should be very brief. 0.96. What is the ratio of the Earning from trade(constant 2005 US) in Bahamas in 2001 to that in 2005?
Make the answer very short. 0.9. What is the ratio of the Earning from trade(constant 2005 US) in Oman in 2001 to that in 2005?
Offer a terse response. 0.92. What is the ratio of the Earning from trade(constant 2005 US) of South Africa in 2001 to that in 2005?
Provide a short and direct response. 0.89. What is the ratio of the Earning from trade(constant 2005 US) in Bahamas in 2001 to that in 2006?
Provide a short and direct response. 0.89. What is the ratio of the Earning from trade(constant 2005 US) in Oman in 2001 to that in 2006?
Offer a very short reply. 1.13. What is the ratio of the Earning from trade(constant 2005 US) of South Africa in 2001 to that in 2006?
Offer a very short reply. 0.82. What is the ratio of the Earning from trade(constant 2005 US) of Bahamas in 2001 to that in 2007?
Give a very brief answer. 0.9. What is the ratio of the Earning from trade(constant 2005 US) of Oman in 2001 to that in 2007?
Offer a very short reply. 1.16. What is the ratio of the Earning from trade(constant 2005 US) in South Africa in 2001 to that in 2007?
Your answer should be compact. 0.76. What is the ratio of the Earning from trade(constant 2005 US) in Bahamas in 2002 to that in 2003?
Your answer should be compact. 0.99. What is the ratio of the Earning from trade(constant 2005 US) in Oman in 2002 to that in 2003?
Your answer should be very brief. 1.03. What is the ratio of the Earning from trade(constant 2005 US) of South Africa in 2002 to that in 2003?
Give a very brief answer. 1. What is the ratio of the Earning from trade(constant 2005 US) of Bahamas in 2002 to that in 2004?
Your answer should be very brief. 0.89. What is the ratio of the Earning from trade(constant 2005 US) in Oman in 2002 to that in 2004?
Ensure brevity in your answer.  1.05. What is the ratio of the Earning from trade(constant 2005 US) in South Africa in 2002 to that in 2004?
Your answer should be compact. 0.97. What is the ratio of the Earning from trade(constant 2005 US) of Bahamas in 2002 to that in 2005?
Provide a short and direct response. 0.91. What is the ratio of the Earning from trade(constant 2005 US) of Oman in 2002 to that in 2005?
Make the answer very short. 0.88. What is the ratio of the Earning from trade(constant 2005 US) in South Africa in 2002 to that in 2005?
Provide a short and direct response. 0.89. What is the ratio of the Earning from trade(constant 2005 US) of Bahamas in 2002 to that in 2006?
Offer a very short reply. 0.89. What is the ratio of the Earning from trade(constant 2005 US) of Oman in 2002 to that in 2006?
Your response must be concise. 1.08. What is the ratio of the Earning from trade(constant 2005 US) of South Africa in 2002 to that in 2006?
Keep it short and to the point. 0.83. What is the ratio of the Earning from trade(constant 2005 US) in Bahamas in 2002 to that in 2007?
Offer a terse response. 0.9. What is the ratio of the Earning from trade(constant 2005 US) in Oman in 2002 to that in 2007?
Your response must be concise. 1.1. What is the ratio of the Earning from trade(constant 2005 US) of South Africa in 2002 to that in 2007?
Your answer should be compact. 0.77. What is the ratio of the Earning from trade(constant 2005 US) of Bahamas in 2003 to that in 2004?
Offer a very short reply. 0.9. What is the ratio of the Earning from trade(constant 2005 US) of Oman in 2003 to that in 2004?
Give a very brief answer. 1.02. What is the ratio of the Earning from trade(constant 2005 US) in South Africa in 2003 to that in 2004?
Offer a very short reply. 0.97. What is the ratio of the Earning from trade(constant 2005 US) of Bahamas in 2003 to that in 2005?
Your answer should be compact. 0.91. What is the ratio of the Earning from trade(constant 2005 US) in Oman in 2003 to that in 2005?
Keep it short and to the point. 0.85. What is the ratio of the Earning from trade(constant 2005 US) of South Africa in 2003 to that in 2005?
Make the answer very short. 0.9. What is the ratio of the Earning from trade(constant 2005 US) of Bahamas in 2003 to that in 2006?
Provide a succinct answer. 0.9. What is the ratio of the Earning from trade(constant 2005 US) of Oman in 2003 to that in 2006?
Your answer should be compact. 1.05. What is the ratio of the Earning from trade(constant 2005 US) in South Africa in 2003 to that in 2006?
Make the answer very short. 0.83. What is the ratio of the Earning from trade(constant 2005 US) of Bahamas in 2003 to that in 2007?
Make the answer very short. 0.91. What is the ratio of the Earning from trade(constant 2005 US) of Oman in 2003 to that in 2007?
Your answer should be compact. 1.07. What is the ratio of the Earning from trade(constant 2005 US) in South Africa in 2003 to that in 2007?
Provide a short and direct response. 0.77. What is the ratio of the Earning from trade(constant 2005 US) in Bahamas in 2004 to that in 2005?
Make the answer very short. 1.02. What is the ratio of the Earning from trade(constant 2005 US) in Oman in 2004 to that in 2005?
Your answer should be very brief. 0.84. What is the ratio of the Earning from trade(constant 2005 US) of South Africa in 2004 to that in 2005?
Your answer should be very brief. 0.92. What is the ratio of the Earning from trade(constant 2005 US) in Bahamas in 2004 to that in 2006?
Offer a terse response. 1. What is the ratio of the Earning from trade(constant 2005 US) in South Africa in 2004 to that in 2006?
Make the answer very short. 0.86. What is the ratio of the Earning from trade(constant 2005 US) in Bahamas in 2004 to that in 2007?
Make the answer very short. 1.02. What is the ratio of the Earning from trade(constant 2005 US) in Oman in 2004 to that in 2007?
Your answer should be very brief. 1.05. What is the ratio of the Earning from trade(constant 2005 US) of South Africa in 2004 to that in 2007?
Your answer should be very brief. 0.79. What is the ratio of the Earning from trade(constant 2005 US) in Bahamas in 2005 to that in 2006?
Keep it short and to the point. 0.98. What is the ratio of the Earning from trade(constant 2005 US) of Oman in 2005 to that in 2006?
Provide a short and direct response. 1.23. What is the ratio of the Earning from trade(constant 2005 US) in South Africa in 2005 to that in 2006?
Ensure brevity in your answer.  0.93. What is the ratio of the Earning from trade(constant 2005 US) of Bahamas in 2005 to that in 2007?
Ensure brevity in your answer.  1. What is the ratio of the Earning from trade(constant 2005 US) in Oman in 2005 to that in 2007?
Make the answer very short. 1.25. What is the ratio of the Earning from trade(constant 2005 US) of South Africa in 2005 to that in 2007?
Your answer should be very brief. 0.86. What is the ratio of the Earning from trade(constant 2005 US) in Bahamas in 2006 to that in 2007?
Ensure brevity in your answer.  1.01. What is the ratio of the Earning from trade(constant 2005 US) in Oman in 2006 to that in 2007?
Provide a succinct answer. 1.02. What is the ratio of the Earning from trade(constant 2005 US) in South Africa in 2006 to that in 2007?
Ensure brevity in your answer.  0.93. What is the difference between the highest and the second highest Earning from trade(constant 2005 US) of Bahamas?
Ensure brevity in your answer.  8.46e+06. What is the difference between the highest and the second highest Earning from trade(constant 2005 US) in Oman?
Provide a short and direct response. 1.40e+09. What is the difference between the highest and the second highest Earning from trade(constant 2005 US) of South Africa?
Keep it short and to the point. 5.73e+09. What is the difference between the highest and the lowest Earning from trade(constant 2005 US) in Bahamas?
Provide a succinct answer. 5.66e+08. What is the difference between the highest and the lowest Earning from trade(constant 2005 US) in Oman?
Your response must be concise. 3.65e+09. What is the difference between the highest and the lowest Earning from trade(constant 2005 US) of South Africa?
Provide a succinct answer. 2.00e+1. 